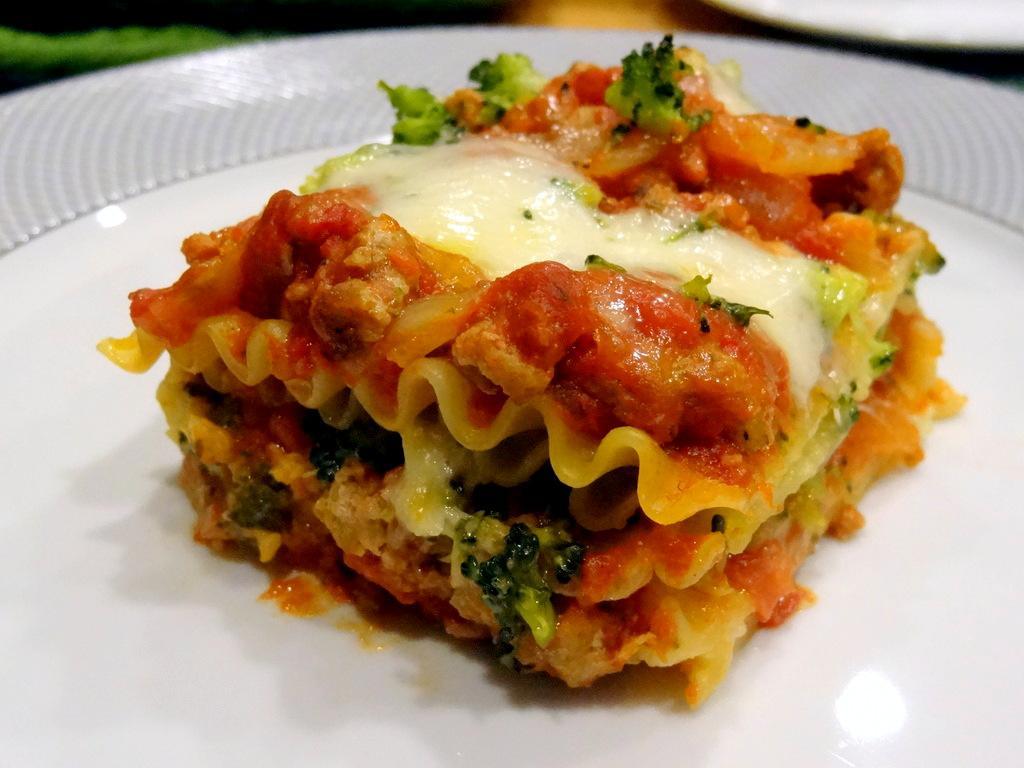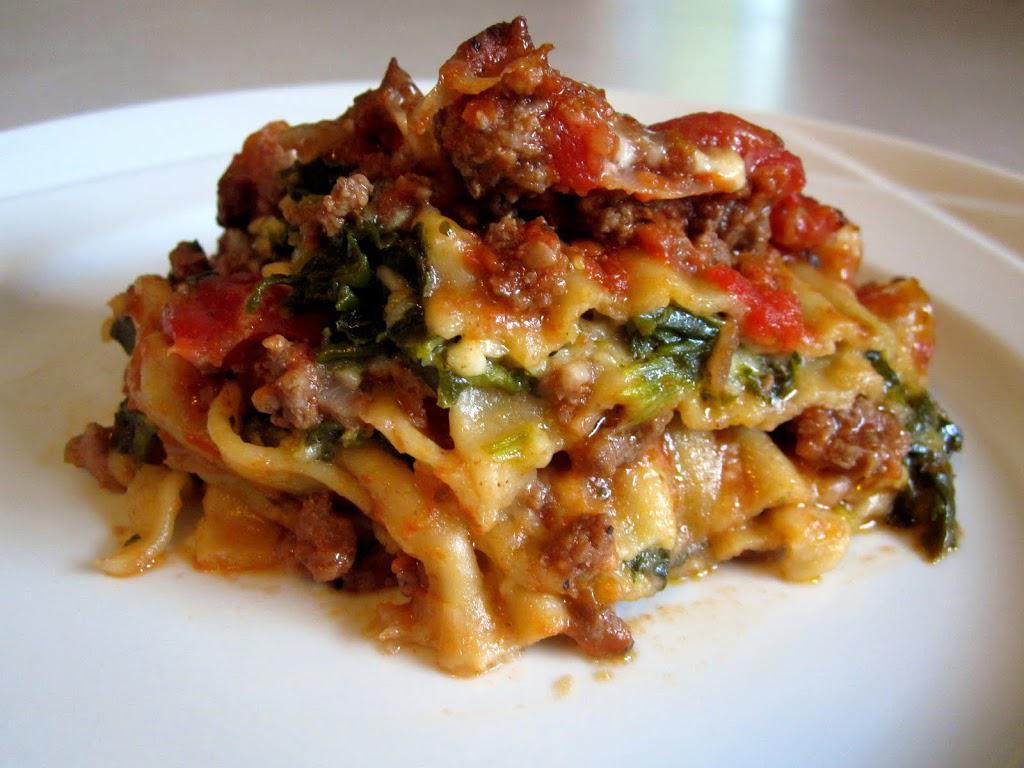The first image is the image on the left, the second image is the image on the right. Assess this claim about the two images: "There is a green leafy garnish on one of the plates of food.". Correct or not? Answer yes or no. No. 